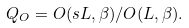<formula> <loc_0><loc_0><loc_500><loc_500>Q _ { O } = O ( s L , \beta ) / O ( L , \beta ) .</formula> 